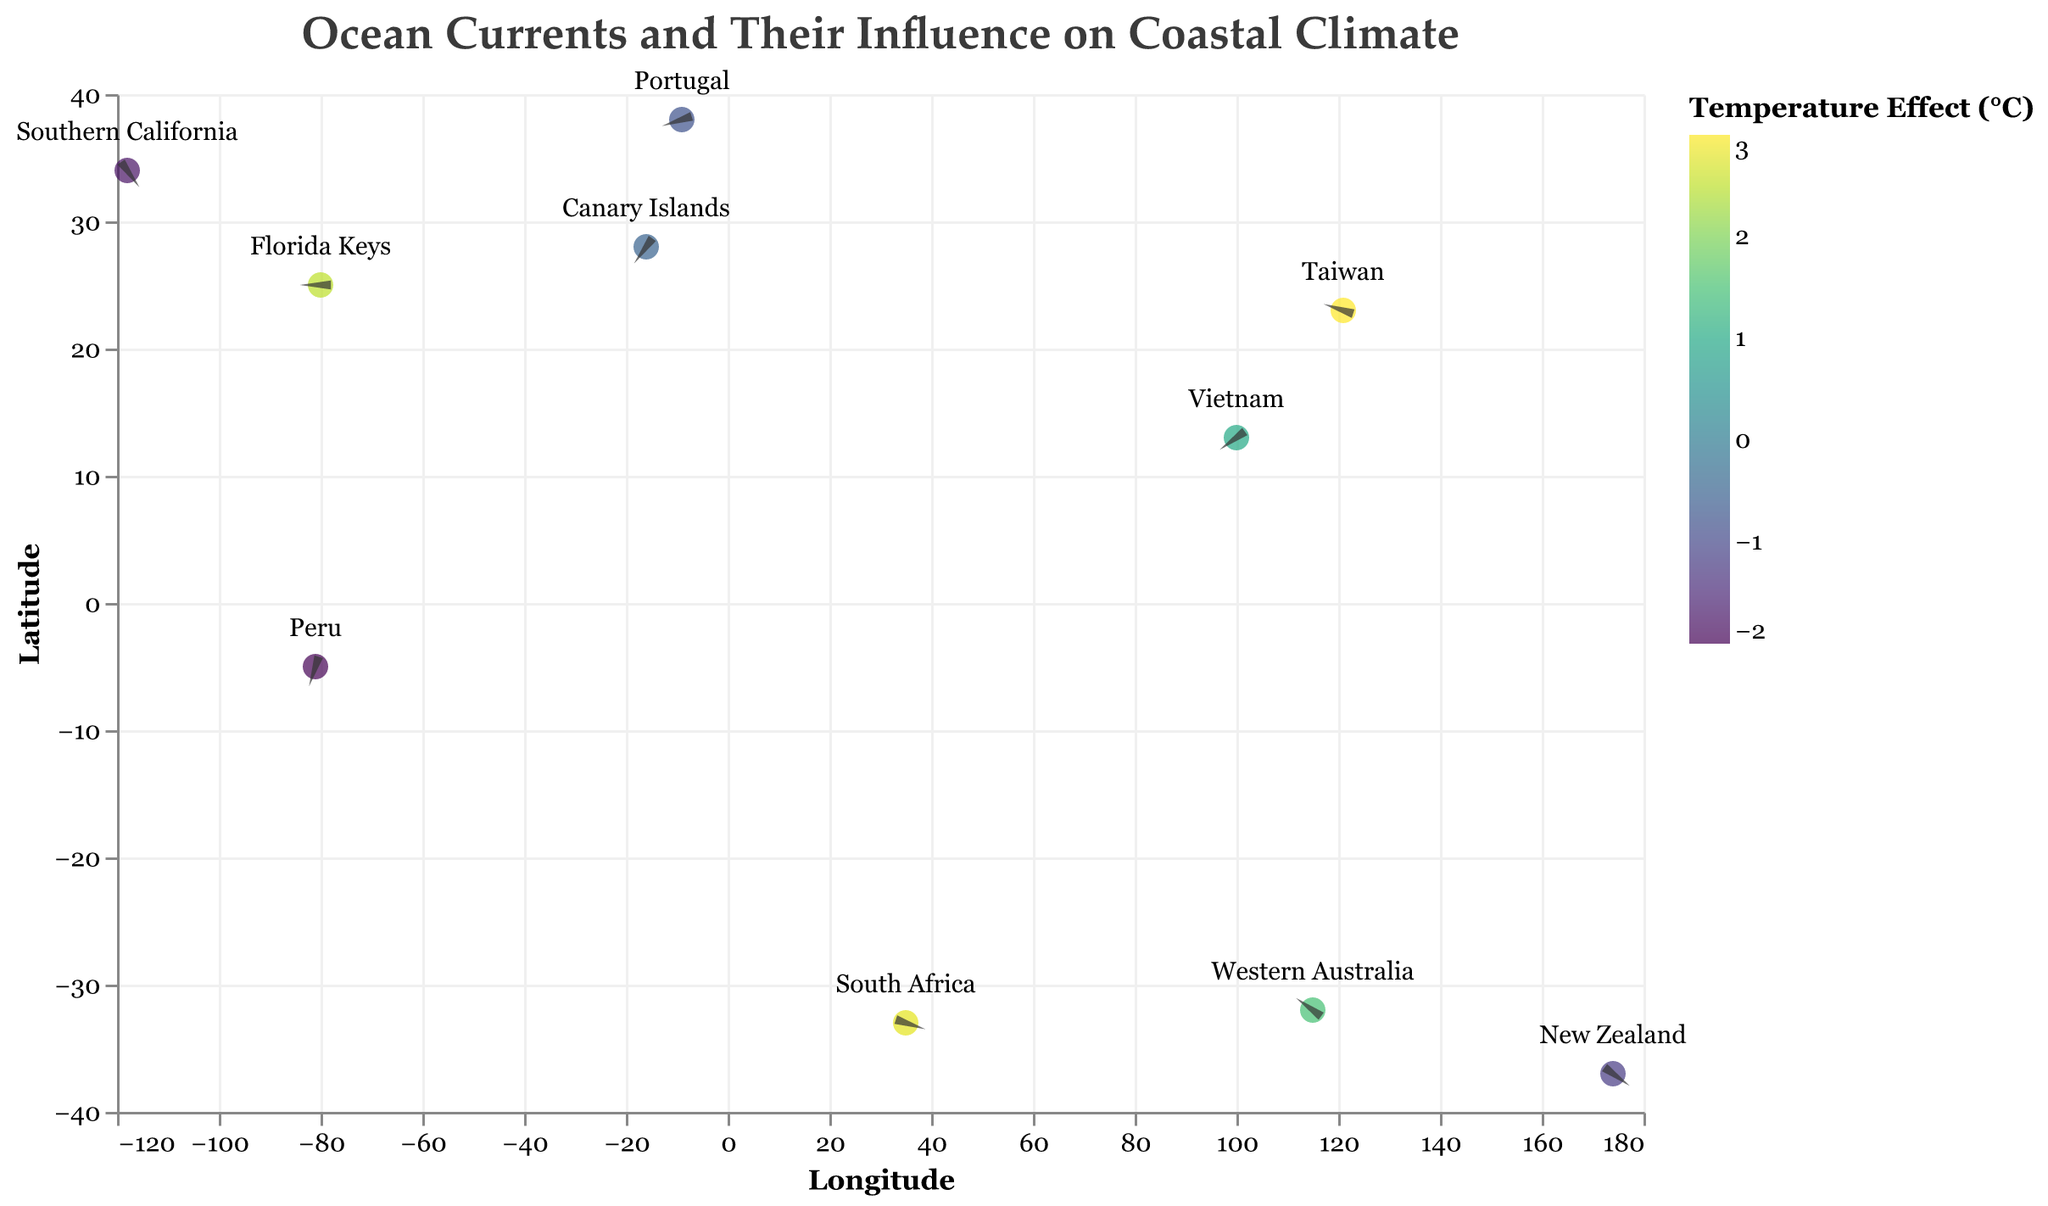What does the title of the figure indicate? The title "Ocean Currents and Their Influence on Coastal Climate" suggests that the figure is depicting various ocean currents and their effects on the temperatures of coastal regions in popular retirement destinations.
Answer: Ocean Currents and Their Influence on Coastal Climate Which location is influenced by the Kuroshio Current and how does it affect the temperature there? Referencing the tooltip data, Taiwan is influenced by the Kuroshio Current, which increases the temperature by 3.0°C.
Answer: Taiwan, 3.0°C What is the temperature effect of the currents at New Zealand and Peru? By examining the tooltips for both locations, it can be observed that the East Auckland Current at New Zealand has a temperature effect of -1.2°C, and the Humboldt Current at Peru has a temperature effect of -2.0°C.
Answer: New Zealand: -1.2°C, Peru: -2.0°C Which ocean current has the highest positive temperature effect, and where is it located? By looking at the color scale and tooltips, the Kuroshio Current has the highest positive temperature effect of 3.0°C, and it is located near Taiwan.
Answer: Kuroshio Current, Taiwan Compare the temperature effects of the Leeuwin Current and the Canary Current. Which one has a higher impact? The tooltip and color scale indicate that the Leeuwin Current near Western Australia has a temperature effect of 1.5°C, whereas the Canary Current near Portugal has a temperature effect of -0.8°C. Therefore, the Leeuwin Current has a higher positive impact.
Answer: Leeuwin Current What angles and directions do the current vectors at Florida Keys and Southern California indicate? The quiver plot shows the vectors, where at Florida Keys, the vector starts at (-80, 25) and goes right 0.5 units and down 0.3 units, indicating a south-east direction. At Southern California, the vector starts at (-118, 34) and goes left 0.2 units and down 0.4 units, indicating a south-west direction.
Answer: Florida Keys: south-east, Southern California: south-west What is the average temperature effect of the currents at the retirement destinations located in the Southern Hemisphere? The destinations in the Southern Hemisphere are New Zealand (-1.2°C), Western Australia (1.5°C), Peru (-2.0°C), and South Africa (2.8°C). The average temperature effect is calculated as (-1.2 + 1.5 - 2.0 + 2.8) / 4 = 0.275°C.
Answer: 0.275°C Which two locations are affected by the Canary Current, and how do their temperature effects compare? The tooltip shows that both Portugal and the Canary Islands are affected by the Canary Current. The temperature effect in Portugal is -0.8°C while it is -0.5°C in the Canary Islands. Hence, Portugal experiences a slightly greater cooling effect.
Answer: Portugal: -0.8°C, Canary Islands: -0.5°C By observing the plot, which locations are influenced by currents that predominantly warm the coastal climate? Locations like the Florida Keys (2.5°C), Taiwan (3.0°C), Western Australia (1.5°C), and South Africa (2.8°C) are influenced by currents that result in a warming effect, as indicated by the positive temperature changes.
Answer: Florida Keys, Taiwan, Western Australia, South Africa 